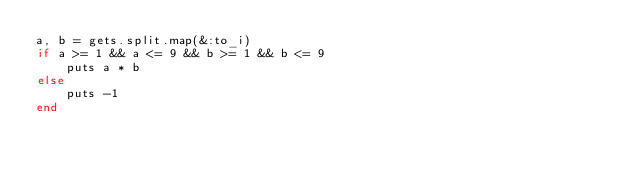<code> <loc_0><loc_0><loc_500><loc_500><_Ruby_>a, b = gets.split.map(&:to_i)
if a >= 1 && a <= 9 && b >= 1 && b <= 9
    puts a * b
else
    puts -1
end</code> 